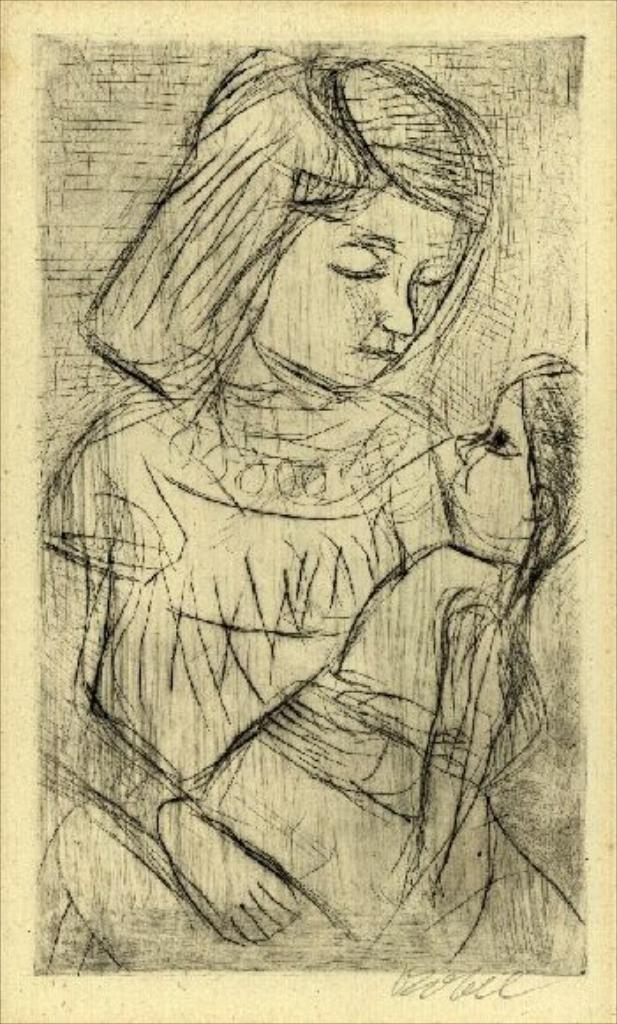What is the main subject of the image? There is a drawing in the image. What does the drawing depict? The drawing depicts a woman. What is the woman holding in the drawing? The woman is holding a doll in the drawing. What color is the sky in the middle of the drawing? There is no sky depicted in the drawing; it is a drawing of a woman holding a doll. How are the items in the drawing sorted? The drawing does not involve sorting items; it depicts a woman holding a doll. 